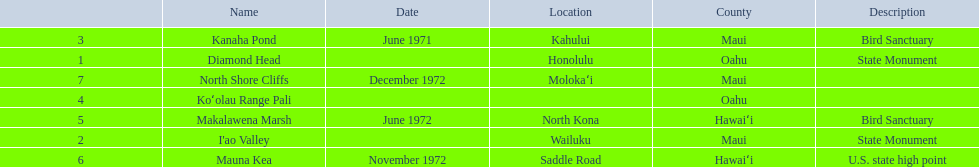How many locations are bird sanctuaries. 2. 